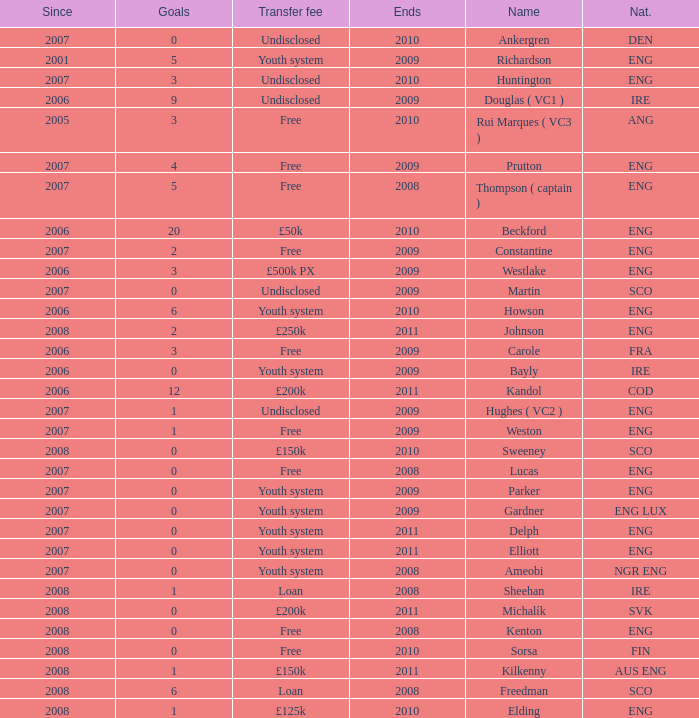Name the average ends for weston 2009.0. 